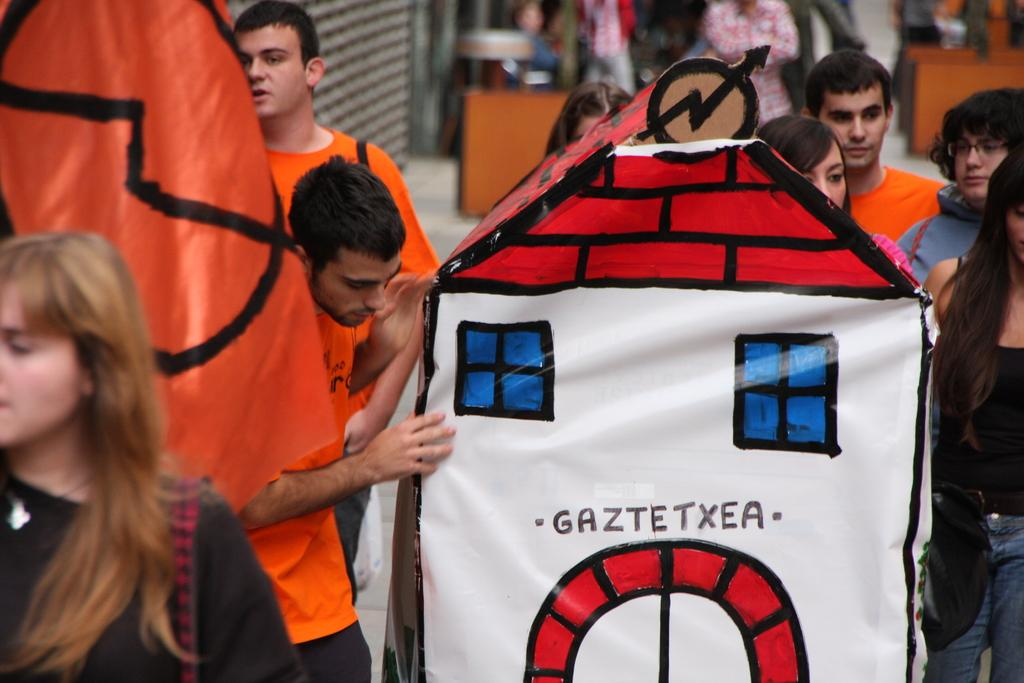Who or what can be seen in the image? There are people in the image. What else is present in the image besides the people? There is an object in the image. Can you describe the background of the image? The background of the image is blurred. What type of payment method is being used in the image? There is no payment method present in the image; it only features people and an object with a blurred background. 